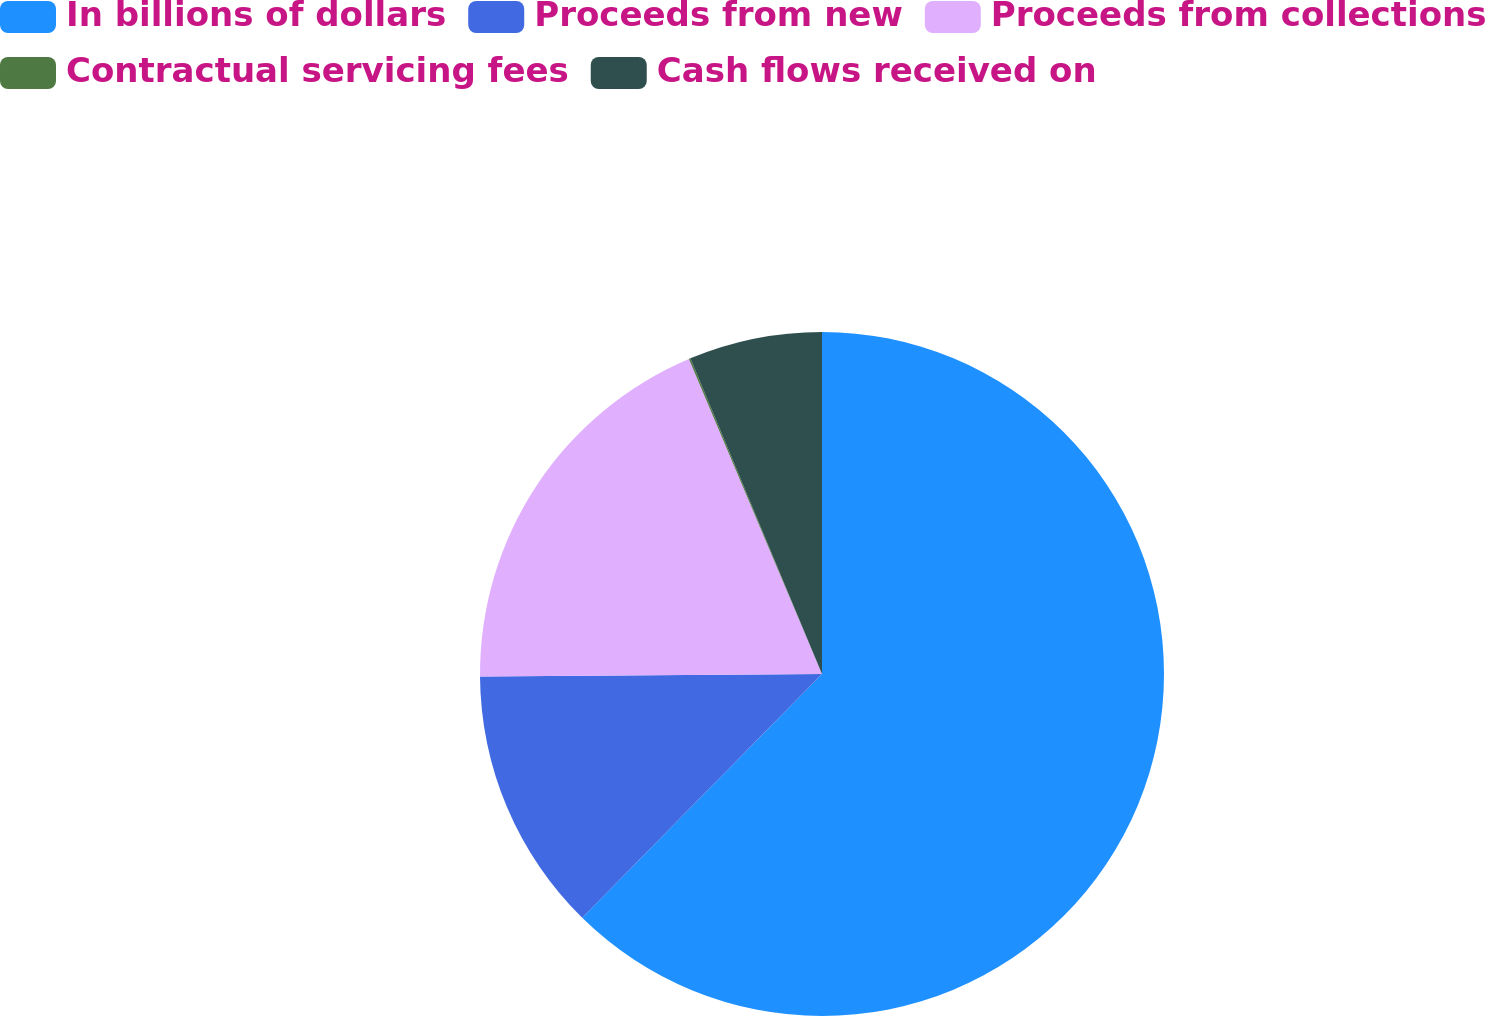Convert chart to OTSL. <chart><loc_0><loc_0><loc_500><loc_500><pie_chart><fcel>In billions of dollars<fcel>Proceeds from new<fcel>Proceeds from collections<fcel>Contractual servicing fees<fcel>Cash flows received on<nl><fcel>62.36%<fcel>12.52%<fcel>18.75%<fcel>0.07%<fcel>6.29%<nl></chart> 